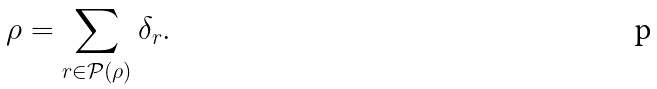<formula> <loc_0><loc_0><loc_500><loc_500>\rho = \sum _ { r \in \mathcal { P } ( \rho ) } \delta _ { r } .</formula> 